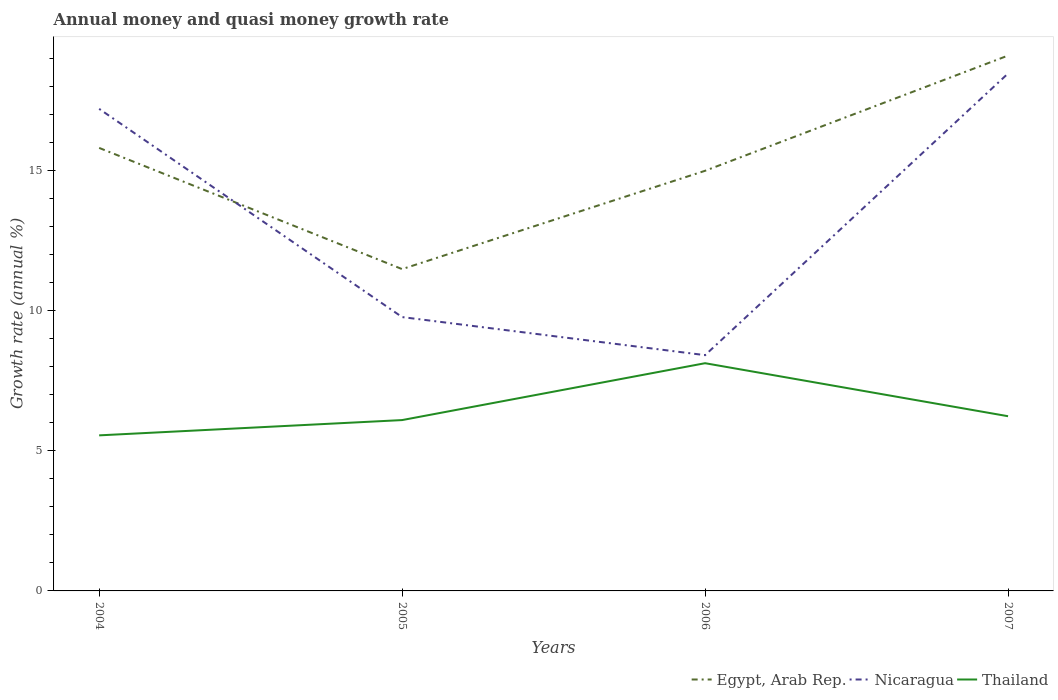How many different coloured lines are there?
Your response must be concise. 3. Does the line corresponding to Egypt, Arab Rep. intersect with the line corresponding to Thailand?
Provide a short and direct response. No. Is the number of lines equal to the number of legend labels?
Give a very brief answer. Yes. Across all years, what is the maximum growth rate in Thailand?
Give a very brief answer. 5.56. What is the total growth rate in Thailand in the graph?
Make the answer very short. -0.68. What is the difference between the highest and the second highest growth rate in Nicaragua?
Make the answer very short. 10.06. What is the difference between the highest and the lowest growth rate in Thailand?
Make the answer very short. 1. Where does the legend appear in the graph?
Ensure brevity in your answer.  Bottom right. What is the title of the graph?
Give a very brief answer. Annual money and quasi money growth rate. What is the label or title of the Y-axis?
Your answer should be compact. Growth rate (annual %). What is the Growth rate (annual %) in Egypt, Arab Rep. in 2004?
Provide a succinct answer. 15.82. What is the Growth rate (annual %) in Nicaragua in 2004?
Offer a very short reply. 17.22. What is the Growth rate (annual %) of Thailand in 2004?
Give a very brief answer. 5.56. What is the Growth rate (annual %) in Egypt, Arab Rep. in 2005?
Your answer should be compact. 11.49. What is the Growth rate (annual %) in Nicaragua in 2005?
Ensure brevity in your answer.  9.78. What is the Growth rate (annual %) in Thailand in 2005?
Give a very brief answer. 6.1. What is the Growth rate (annual %) of Egypt, Arab Rep. in 2006?
Give a very brief answer. 15. What is the Growth rate (annual %) of Nicaragua in 2006?
Offer a very short reply. 8.42. What is the Growth rate (annual %) in Thailand in 2006?
Your response must be concise. 8.13. What is the Growth rate (annual %) in Egypt, Arab Rep. in 2007?
Offer a terse response. 19.12. What is the Growth rate (annual %) of Nicaragua in 2007?
Provide a succinct answer. 18.48. What is the Growth rate (annual %) in Thailand in 2007?
Ensure brevity in your answer.  6.24. Across all years, what is the maximum Growth rate (annual %) of Egypt, Arab Rep.?
Make the answer very short. 19.12. Across all years, what is the maximum Growth rate (annual %) of Nicaragua?
Your answer should be compact. 18.48. Across all years, what is the maximum Growth rate (annual %) in Thailand?
Offer a very short reply. 8.13. Across all years, what is the minimum Growth rate (annual %) in Egypt, Arab Rep.?
Give a very brief answer. 11.49. Across all years, what is the minimum Growth rate (annual %) of Nicaragua?
Your response must be concise. 8.42. Across all years, what is the minimum Growth rate (annual %) of Thailand?
Provide a short and direct response. 5.56. What is the total Growth rate (annual %) in Egypt, Arab Rep. in the graph?
Your answer should be very brief. 61.44. What is the total Growth rate (annual %) in Nicaragua in the graph?
Your answer should be very brief. 53.9. What is the total Growth rate (annual %) of Thailand in the graph?
Ensure brevity in your answer.  26.03. What is the difference between the Growth rate (annual %) in Egypt, Arab Rep. in 2004 and that in 2005?
Ensure brevity in your answer.  4.33. What is the difference between the Growth rate (annual %) in Nicaragua in 2004 and that in 2005?
Provide a short and direct response. 7.44. What is the difference between the Growth rate (annual %) of Thailand in 2004 and that in 2005?
Provide a short and direct response. -0.55. What is the difference between the Growth rate (annual %) in Egypt, Arab Rep. in 2004 and that in 2006?
Your answer should be very brief. 0.82. What is the difference between the Growth rate (annual %) of Nicaragua in 2004 and that in 2006?
Your answer should be compact. 8.8. What is the difference between the Growth rate (annual %) of Thailand in 2004 and that in 2006?
Give a very brief answer. -2.58. What is the difference between the Growth rate (annual %) in Egypt, Arab Rep. in 2004 and that in 2007?
Your response must be concise. -3.3. What is the difference between the Growth rate (annual %) in Nicaragua in 2004 and that in 2007?
Make the answer very short. -1.26. What is the difference between the Growth rate (annual %) of Thailand in 2004 and that in 2007?
Your answer should be compact. -0.68. What is the difference between the Growth rate (annual %) in Egypt, Arab Rep. in 2005 and that in 2006?
Offer a terse response. -3.51. What is the difference between the Growth rate (annual %) of Nicaragua in 2005 and that in 2006?
Provide a short and direct response. 1.36. What is the difference between the Growth rate (annual %) of Thailand in 2005 and that in 2006?
Offer a terse response. -2.03. What is the difference between the Growth rate (annual %) of Egypt, Arab Rep. in 2005 and that in 2007?
Offer a terse response. -7.63. What is the difference between the Growth rate (annual %) in Nicaragua in 2005 and that in 2007?
Your answer should be very brief. -8.7. What is the difference between the Growth rate (annual %) of Thailand in 2005 and that in 2007?
Make the answer very short. -0.14. What is the difference between the Growth rate (annual %) of Egypt, Arab Rep. in 2006 and that in 2007?
Offer a terse response. -4.11. What is the difference between the Growth rate (annual %) in Nicaragua in 2006 and that in 2007?
Offer a very short reply. -10.06. What is the difference between the Growth rate (annual %) of Thailand in 2006 and that in 2007?
Provide a succinct answer. 1.89. What is the difference between the Growth rate (annual %) of Egypt, Arab Rep. in 2004 and the Growth rate (annual %) of Nicaragua in 2005?
Offer a terse response. 6.04. What is the difference between the Growth rate (annual %) in Egypt, Arab Rep. in 2004 and the Growth rate (annual %) in Thailand in 2005?
Your answer should be compact. 9.72. What is the difference between the Growth rate (annual %) in Nicaragua in 2004 and the Growth rate (annual %) in Thailand in 2005?
Make the answer very short. 11.12. What is the difference between the Growth rate (annual %) of Egypt, Arab Rep. in 2004 and the Growth rate (annual %) of Nicaragua in 2006?
Your response must be concise. 7.4. What is the difference between the Growth rate (annual %) of Egypt, Arab Rep. in 2004 and the Growth rate (annual %) of Thailand in 2006?
Your answer should be compact. 7.69. What is the difference between the Growth rate (annual %) of Nicaragua in 2004 and the Growth rate (annual %) of Thailand in 2006?
Provide a short and direct response. 9.08. What is the difference between the Growth rate (annual %) of Egypt, Arab Rep. in 2004 and the Growth rate (annual %) of Nicaragua in 2007?
Offer a very short reply. -2.66. What is the difference between the Growth rate (annual %) in Egypt, Arab Rep. in 2004 and the Growth rate (annual %) in Thailand in 2007?
Your answer should be very brief. 9.58. What is the difference between the Growth rate (annual %) in Nicaragua in 2004 and the Growth rate (annual %) in Thailand in 2007?
Your answer should be compact. 10.98. What is the difference between the Growth rate (annual %) in Egypt, Arab Rep. in 2005 and the Growth rate (annual %) in Nicaragua in 2006?
Offer a very short reply. 3.07. What is the difference between the Growth rate (annual %) in Egypt, Arab Rep. in 2005 and the Growth rate (annual %) in Thailand in 2006?
Offer a terse response. 3.36. What is the difference between the Growth rate (annual %) of Nicaragua in 2005 and the Growth rate (annual %) of Thailand in 2006?
Give a very brief answer. 1.65. What is the difference between the Growth rate (annual %) in Egypt, Arab Rep. in 2005 and the Growth rate (annual %) in Nicaragua in 2007?
Keep it short and to the point. -6.99. What is the difference between the Growth rate (annual %) of Egypt, Arab Rep. in 2005 and the Growth rate (annual %) of Thailand in 2007?
Keep it short and to the point. 5.25. What is the difference between the Growth rate (annual %) of Nicaragua in 2005 and the Growth rate (annual %) of Thailand in 2007?
Offer a terse response. 3.54. What is the difference between the Growth rate (annual %) of Egypt, Arab Rep. in 2006 and the Growth rate (annual %) of Nicaragua in 2007?
Offer a very short reply. -3.47. What is the difference between the Growth rate (annual %) in Egypt, Arab Rep. in 2006 and the Growth rate (annual %) in Thailand in 2007?
Ensure brevity in your answer.  8.77. What is the difference between the Growth rate (annual %) of Nicaragua in 2006 and the Growth rate (annual %) of Thailand in 2007?
Your answer should be very brief. 2.18. What is the average Growth rate (annual %) of Egypt, Arab Rep. per year?
Your response must be concise. 15.36. What is the average Growth rate (annual %) of Nicaragua per year?
Your answer should be very brief. 13.47. What is the average Growth rate (annual %) of Thailand per year?
Keep it short and to the point. 6.51. In the year 2004, what is the difference between the Growth rate (annual %) of Egypt, Arab Rep. and Growth rate (annual %) of Nicaragua?
Offer a terse response. -1.39. In the year 2004, what is the difference between the Growth rate (annual %) of Egypt, Arab Rep. and Growth rate (annual %) of Thailand?
Your response must be concise. 10.27. In the year 2004, what is the difference between the Growth rate (annual %) in Nicaragua and Growth rate (annual %) in Thailand?
Provide a succinct answer. 11.66. In the year 2005, what is the difference between the Growth rate (annual %) in Egypt, Arab Rep. and Growth rate (annual %) in Nicaragua?
Make the answer very short. 1.71. In the year 2005, what is the difference between the Growth rate (annual %) in Egypt, Arab Rep. and Growth rate (annual %) in Thailand?
Make the answer very short. 5.39. In the year 2005, what is the difference between the Growth rate (annual %) in Nicaragua and Growth rate (annual %) in Thailand?
Your answer should be compact. 3.68. In the year 2006, what is the difference between the Growth rate (annual %) in Egypt, Arab Rep. and Growth rate (annual %) in Nicaragua?
Keep it short and to the point. 6.58. In the year 2006, what is the difference between the Growth rate (annual %) in Egypt, Arab Rep. and Growth rate (annual %) in Thailand?
Offer a very short reply. 6.87. In the year 2006, what is the difference between the Growth rate (annual %) of Nicaragua and Growth rate (annual %) of Thailand?
Offer a very short reply. 0.29. In the year 2007, what is the difference between the Growth rate (annual %) of Egypt, Arab Rep. and Growth rate (annual %) of Nicaragua?
Offer a very short reply. 0.64. In the year 2007, what is the difference between the Growth rate (annual %) in Egypt, Arab Rep. and Growth rate (annual %) in Thailand?
Give a very brief answer. 12.88. In the year 2007, what is the difference between the Growth rate (annual %) of Nicaragua and Growth rate (annual %) of Thailand?
Your response must be concise. 12.24. What is the ratio of the Growth rate (annual %) of Egypt, Arab Rep. in 2004 to that in 2005?
Give a very brief answer. 1.38. What is the ratio of the Growth rate (annual %) of Nicaragua in 2004 to that in 2005?
Offer a very short reply. 1.76. What is the ratio of the Growth rate (annual %) of Thailand in 2004 to that in 2005?
Keep it short and to the point. 0.91. What is the ratio of the Growth rate (annual %) in Egypt, Arab Rep. in 2004 to that in 2006?
Ensure brevity in your answer.  1.05. What is the ratio of the Growth rate (annual %) of Nicaragua in 2004 to that in 2006?
Offer a very short reply. 2.04. What is the ratio of the Growth rate (annual %) in Thailand in 2004 to that in 2006?
Ensure brevity in your answer.  0.68. What is the ratio of the Growth rate (annual %) in Egypt, Arab Rep. in 2004 to that in 2007?
Your answer should be very brief. 0.83. What is the ratio of the Growth rate (annual %) in Nicaragua in 2004 to that in 2007?
Your answer should be compact. 0.93. What is the ratio of the Growth rate (annual %) of Thailand in 2004 to that in 2007?
Make the answer very short. 0.89. What is the ratio of the Growth rate (annual %) in Egypt, Arab Rep. in 2005 to that in 2006?
Give a very brief answer. 0.77. What is the ratio of the Growth rate (annual %) of Nicaragua in 2005 to that in 2006?
Offer a very short reply. 1.16. What is the ratio of the Growth rate (annual %) of Thailand in 2005 to that in 2006?
Offer a terse response. 0.75. What is the ratio of the Growth rate (annual %) in Egypt, Arab Rep. in 2005 to that in 2007?
Make the answer very short. 0.6. What is the ratio of the Growth rate (annual %) in Nicaragua in 2005 to that in 2007?
Offer a terse response. 0.53. What is the ratio of the Growth rate (annual %) in Thailand in 2005 to that in 2007?
Provide a succinct answer. 0.98. What is the ratio of the Growth rate (annual %) in Egypt, Arab Rep. in 2006 to that in 2007?
Give a very brief answer. 0.78. What is the ratio of the Growth rate (annual %) of Nicaragua in 2006 to that in 2007?
Offer a terse response. 0.46. What is the ratio of the Growth rate (annual %) of Thailand in 2006 to that in 2007?
Your answer should be very brief. 1.3. What is the difference between the highest and the second highest Growth rate (annual %) in Egypt, Arab Rep.?
Offer a very short reply. 3.3. What is the difference between the highest and the second highest Growth rate (annual %) of Nicaragua?
Offer a terse response. 1.26. What is the difference between the highest and the second highest Growth rate (annual %) in Thailand?
Keep it short and to the point. 1.89. What is the difference between the highest and the lowest Growth rate (annual %) of Egypt, Arab Rep.?
Provide a short and direct response. 7.63. What is the difference between the highest and the lowest Growth rate (annual %) in Nicaragua?
Make the answer very short. 10.06. What is the difference between the highest and the lowest Growth rate (annual %) in Thailand?
Your response must be concise. 2.58. 